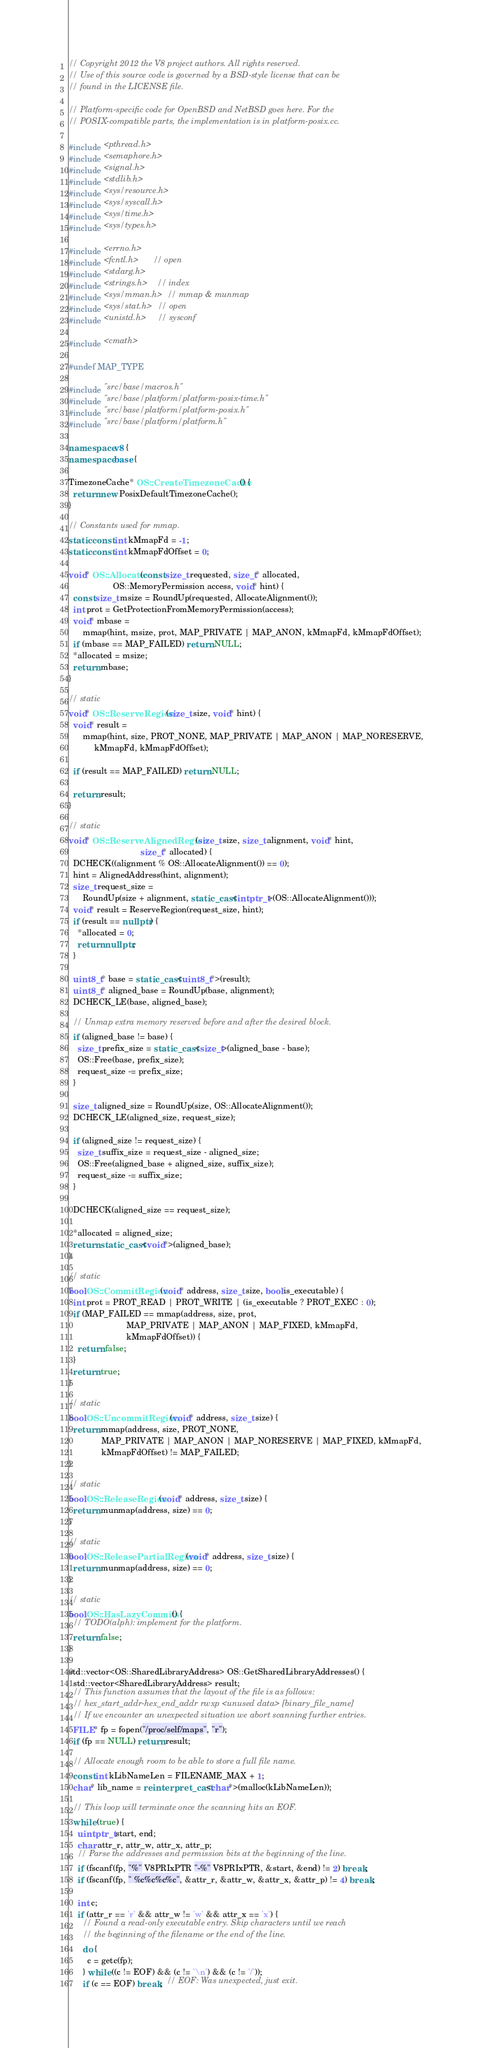<code> <loc_0><loc_0><loc_500><loc_500><_C++_>// Copyright 2012 the V8 project authors. All rights reserved.
// Use of this source code is governed by a BSD-style license that can be
// found in the LICENSE file.

// Platform-specific code for OpenBSD and NetBSD goes here. For the
// POSIX-compatible parts, the implementation is in platform-posix.cc.

#include <pthread.h>
#include <semaphore.h>
#include <signal.h>
#include <stdlib.h>
#include <sys/resource.h>
#include <sys/syscall.h>
#include <sys/time.h>
#include <sys/types.h>

#include <errno.h>
#include <fcntl.h>      // open
#include <stdarg.h>
#include <strings.h>    // index
#include <sys/mman.h>   // mmap & munmap
#include <sys/stat.h>   // open
#include <unistd.h>     // sysconf

#include <cmath>

#undef MAP_TYPE

#include "src/base/macros.h"
#include "src/base/platform/platform-posix-time.h"
#include "src/base/platform/platform-posix.h"
#include "src/base/platform/platform.h"

namespace v8 {
namespace base {

TimezoneCache* OS::CreateTimezoneCache() {
  return new PosixDefaultTimezoneCache();
}

// Constants used for mmap.
static const int kMmapFd = -1;
static const int kMmapFdOffset = 0;

void* OS::Allocate(const size_t requested, size_t* allocated,
                   OS::MemoryPermission access, void* hint) {
  const size_t msize = RoundUp(requested, AllocateAlignment());
  int prot = GetProtectionFromMemoryPermission(access);
  void* mbase =
      mmap(hint, msize, prot, MAP_PRIVATE | MAP_ANON, kMmapFd, kMmapFdOffset);
  if (mbase == MAP_FAILED) return NULL;
  *allocated = msize;
  return mbase;
}

// static
void* OS::ReserveRegion(size_t size, void* hint) {
  void* result =
      mmap(hint, size, PROT_NONE, MAP_PRIVATE | MAP_ANON | MAP_NORESERVE,
           kMmapFd, kMmapFdOffset);

  if (result == MAP_FAILED) return NULL;

  return result;
}

// static
void* OS::ReserveAlignedRegion(size_t size, size_t alignment, void* hint,
                               size_t* allocated) {
  DCHECK((alignment % OS::AllocateAlignment()) == 0);
  hint = AlignedAddress(hint, alignment);
  size_t request_size =
      RoundUp(size + alignment, static_cast<intptr_t>(OS::AllocateAlignment()));
  void* result = ReserveRegion(request_size, hint);
  if (result == nullptr) {
    *allocated = 0;
    return nullptr;
  }

  uint8_t* base = static_cast<uint8_t*>(result);
  uint8_t* aligned_base = RoundUp(base, alignment);
  DCHECK_LE(base, aligned_base);

  // Unmap extra memory reserved before and after the desired block.
  if (aligned_base != base) {
    size_t prefix_size = static_cast<size_t>(aligned_base - base);
    OS::Free(base, prefix_size);
    request_size -= prefix_size;
  }

  size_t aligned_size = RoundUp(size, OS::AllocateAlignment());
  DCHECK_LE(aligned_size, request_size);

  if (aligned_size != request_size) {
    size_t suffix_size = request_size - aligned_size;
    OS::Free(aligned_base + aligned_size, suffix_size);
    request_size -= suffix_size;
  }

  DCHECK(aligned_size == request_size);

  *allocated = aligned_size;
  return static_cast<void*>(aligned_base);
}

// static
bool OS::CommitRegion(void* address, size_t size, bool is_executable) {
  int prot = PROT_READ | PROT_WRITE | (is_executable ? PROT_EXEC : 0);
  if (MAP_FAILED == mmap(address, size, prot,
                         MAP_PRIVATE | MAP_ANON | MAP_FIXED, kMmapFd,
                         kMmapFdOffset)) {
    return false;
  }
  return true;
}

// static
bool OS::UncommitRegion(void* address, size_t size) {
  return mmap(address, size, PROT_NONE,
              MAP_PRIVATE | MAP_ANON | MAP_NORESERVE | MAP_FIXED, kMmapFd,
              kMmapFdOffset) != MAP_FAILED;
}

// static
bool OS::ReleaseRegion(void* address, size_t size) {
  return munmap(address, size) == 0;
}

// static
bool OS::ReleasePartialRegion(void* address, size_t size) {
  return munmap(address, size) == 0;
}

// static
bool OS::HasLazyCommits() {
  // TODO(alph): implement for the platform.
  return false;
}

std::vector<OS::SharedLibraryAddress> OS::GetSharedLibraryAddresses() {
  std::vector<SharedLibraryAddress> result;
  // This function assumes that the layout of the file is as follows:
  // hex_start_addr-hex_end_addr rwxp <unused data> [binary_file_name]
  // If we encounter an unexpected situation we abort scanning further entries.
  FILE* fp = fopen("/proc/self/maps", "r");
  if (fp == NULL) return result;

  // Allocate enough room to be able to store a full file name.
  const int kLibNameLen = FILENAME_MAX + 1;
  char* lib_name = reinterpret_cast<char*>(malloc(kLibNameLen));

  // This loop will terminate once the scanning hits an EOF.
  while (true) {
    uintptr_t start, end;
    char attr_r, attr_w, attr_x, attr_p;
    // Parse the addresses and permission bits at the beginning of the line.
    if (fscanf(fp, "%" V8PRIxPTR "-%" V8PRIxPTR, &start, &end) != 2) break;
    if (fscanf(fp, " %c%c%c%c", &attr_r, &attr_w, &attr_x, &attr_p) != 4) break;

    int c;
    if (attr_r == 'r' && attr_w != 'w' && attr_x == 'x') {
      // Found a read-only executable entry. Skip characters until we reach
      // the beginning of the filename or the end of the line.
      do {
        c = getc(fp);
      } while ((c != EOF) && (c != '\n') && (c != '/'));
      if (c == EOF) break;  // EOF: Was unexpected, just exit.
</code> 